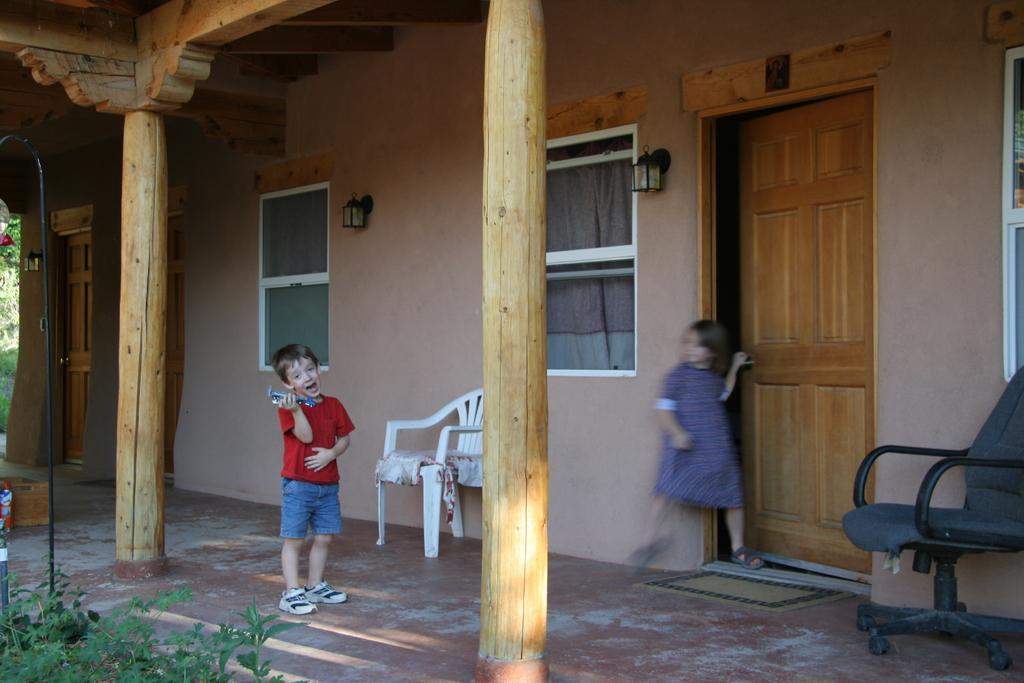Can you describe this image briefly? In this image, There is a floor of brown color and there are two poles made of wood which in yellow color, In the middle there is a boy standing and holding some object in his hand, In the right side there is a chair in black color, And there is a door in yellow color and a girl standing beside the door. 